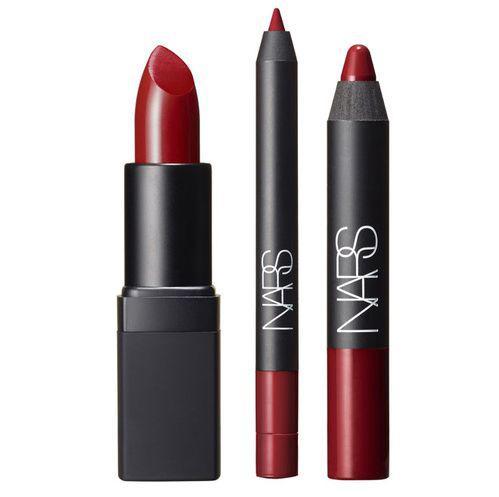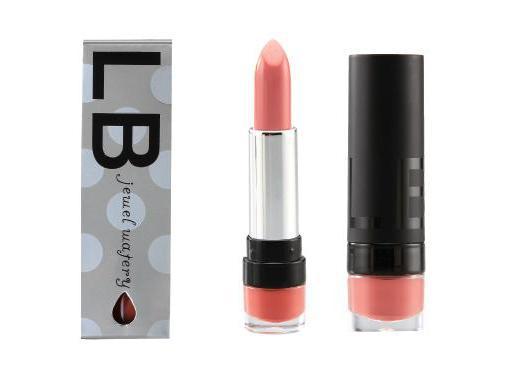The first image is the image on the left, the second image is the image on the right. Given the left and right images, does the statement "An image shows a row of three items, including a narrow box." hold true? Answer yes or no. Yes. 